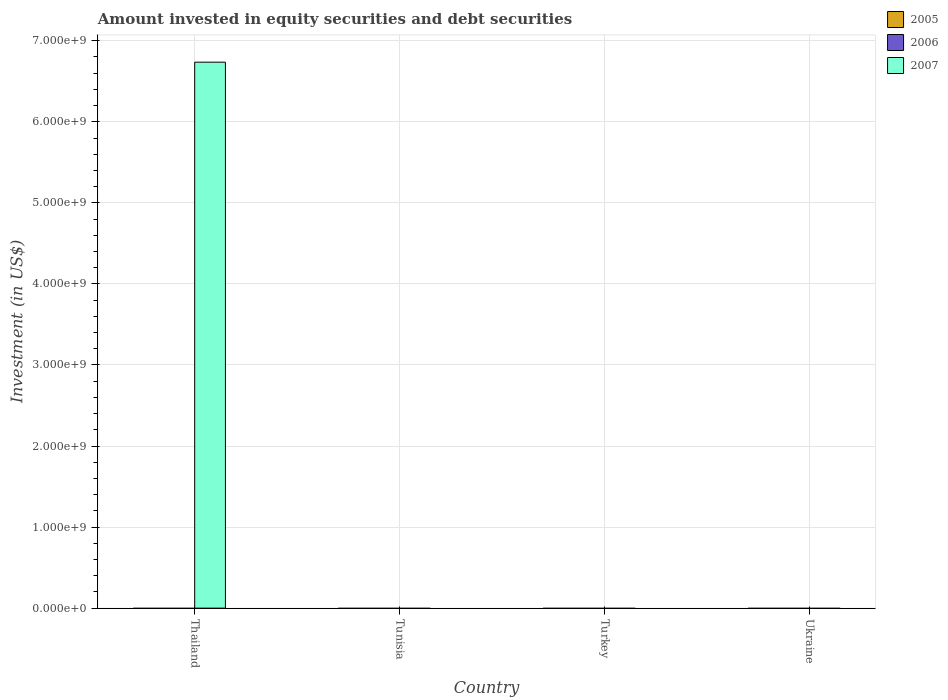Are the number of bars per tick equal to the number of legend labels?
Your answer should be compact. No. How many bars are there on the 1st tick from the left?
Provide a short and direct response. 1. How many bars are there on the 1st tick from the right?
Your answer should be very brief. 0. What is the label of the 1st group of bars from the left?
Your response must be concise. Thailand. In how many cases, is the number of bars for a given country not equal to the number of legend labels?
Give a very brief answer. 4. What is the amount invested in equity securities and debt securities in 2007 in Thailand?
Give a very brief answer. 6.74e+09. Across all countries, what is the maximum amount invested in equity securities and debt securities in 2007?
Your response must be concise. 6.74e+09. In which country was the amount invested in equity securities and debt securities in 2007 maximum?
Offer a terse response. Thailand. What is the total amount invested in equity securities and debt securities in 2006 in the graph?
Give a very brief answer. 0. What is the average amount invested in equity securities and debt securities in 2006 per country?
Keep it short and to the point. 0. What is the difference between the highest and the lowest amount invested in equity securities and debt securities in 2007?
Provide a short and direct response. 6.74e+09. How many bars are there?
Offer a terse response. 1. What is the difference between two consecutive major ticks on the Y-axis?
Make the answer very short. 1.00e+09. Are the values on the major ticks of Y-axis written in scientific E-notation?
Provide a succinct answer. Yes. Does the graph contain grids?
Give a very brief answer. Yes. What is the title of the graph?
Your answer should be very brief. Amount invested in equity securities and debt securities. What is the label or title of the Y-axis?
Offer a very short reply. Investment (in US$). What is the Investment (in US$) of 2005 in Thailand?
Your answer should be very brief. 0. What is the Investment (in US$) of 2006 in Thailand?
Ensure brevity in your answer.  0. What is the Investment (in US$) of 2007 in Thailand?
Offer a very short reply. 6.74e+09. What is the Investment (in US$) in 2006 in Tunisia?
Provide a succinct answer. 0. What is the Investment (in US$) in 2007 in Tunisia?
Provide a succinct answer. 0. What is the Investment (in US$) in 2005 in Turkey?
Your answer should be compact. 0. What is the Investment (in US$) in 2006 in Turkey?
Provide a succinct answer. 0. What is the Investment (in US$) in 2005 in Ukraine?
Ensure brevity in your answer.  0. What is the Investment (in US$) in 2006 in Ukraine?
Ensure brevity in your answer.  0. What is the Investment (in US$) in 2007 in Ukraine?
Your answer should be compact. 0. Across all countries, what is the maximum Investment (in US$) in 2007?
Offer a very short reply. 6.74e+09. Across all countries, what is the minimum Investment (in US$) in 2007?
Ensure brevity in your answer.  0. What is the total Investment (in US$) in 2007 in the graph?
Your answer should be compact. 6.74e+09. What is the average Investment (in US$) in 2005 per country?
Offer a terse response. 0. What is the average Investment (in US$) of 2006 per country?
Provide a succinct answer. 0. What is the average Investment (in US$) of 2007 per country?
Provide a succinct answer. 1.68e+09. What is the difference between the highest and the lowest Investment (in US$) of 2007?
Your answer should be very brief. 6.74e+09. 